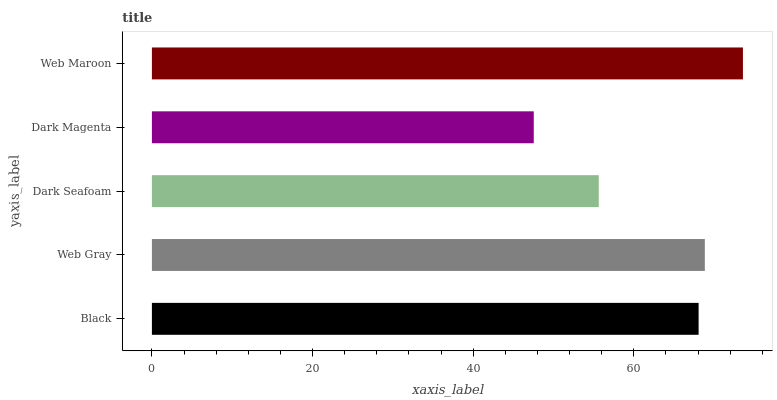Is Dark Magenta the minimum?
Answer yes or no. Yes. Is Web Maroon the maximum?
Answer yes or no. Yes. Is Web Gray the minimum?
Answer yes or no. No. Is Web Gray the maximum?
Answer yes or no. No. Is Web Gray greater than Black?
Answer yes or no. Yes. Is Black less than Web Gray?
Answer yes or no. Yes. Is Black greater than Web Gray?
Answer yes or no. No. Is Web Gray less than Black?
Answer yes or no. No. Is Black the high median?
Answer yes or no. Yes. Is Black the low median?
Answer yes or no. Yes. Is Web Gray the high median?
Answer yes or no. No. Is Dark Seafoam the low median?
Answer yes or no. No. 